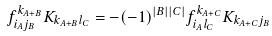Convert formula to latex. <formula><loc_0><loc_0><loc_500><loc_500>f _ { i _ { A } j _ { B } } ^ { k _ { A + B } } K _ { k _ { A + B } l _ { C } } = - ( - 1 ) ^ { | B | | C | } f _ { i _ { A } l _ { C } } ^ { k _ { A + C } } K _ { k _ { A + C } j _ { B } } \</formula> 